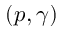Convert formula to latex. <formula><loc_0><loc_0><loc_500><loc_500>( p , \gamma )</formula> 